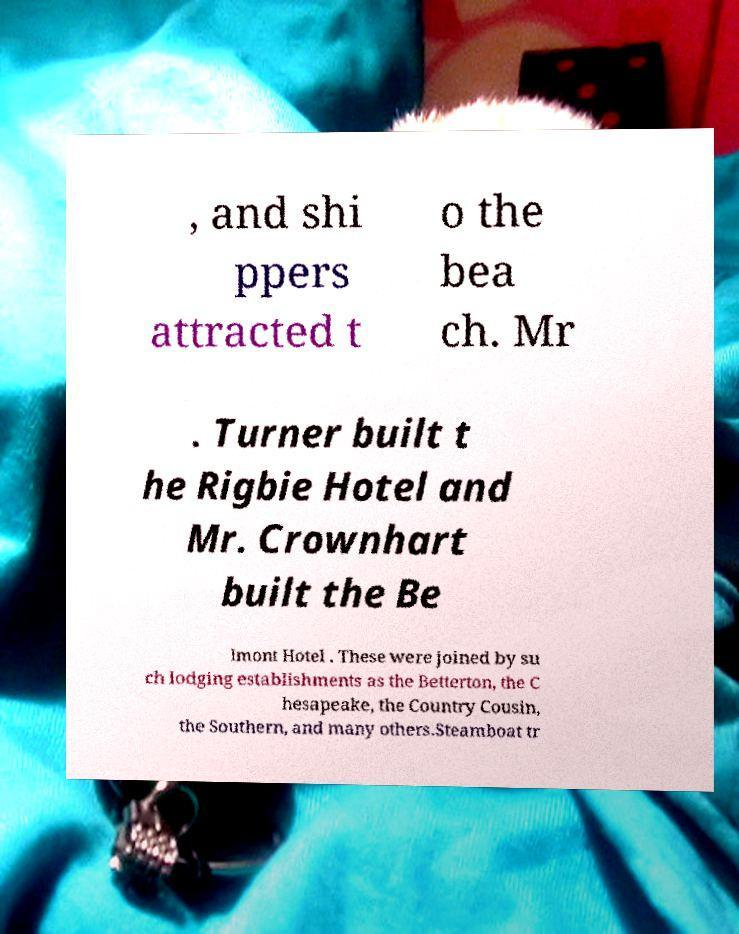Could you extract and type out the text from this image? , and shi ppers attracted t o the bea ch. Mr . Turner built t he Rigbie Hotel and Mr. Crownhart built the Be lmont Hotel . These were joined by su ch lodging establishments as the Betterton, the C hesapeake, the Country Cousin, the Southern, and many others.Steamboat tr 